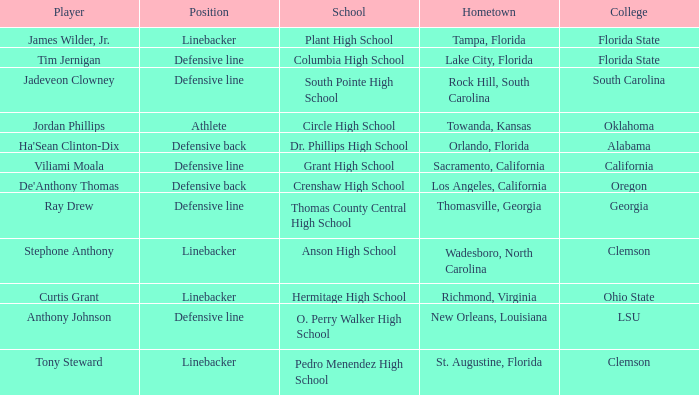Which hometown has a player of Ray Drew? Thomasville, Georgia. 